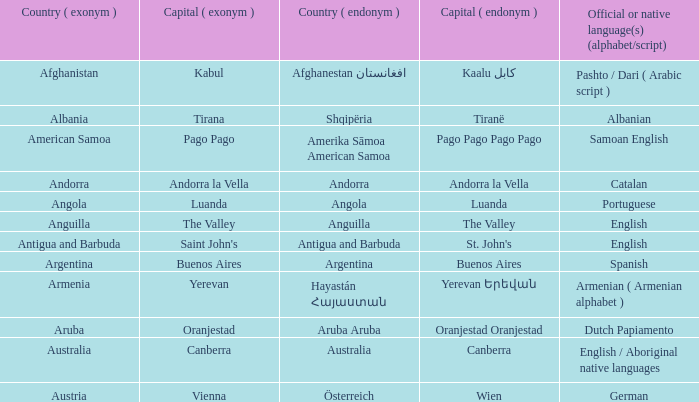What is the local name given to the city of Canberra? Canberra. 